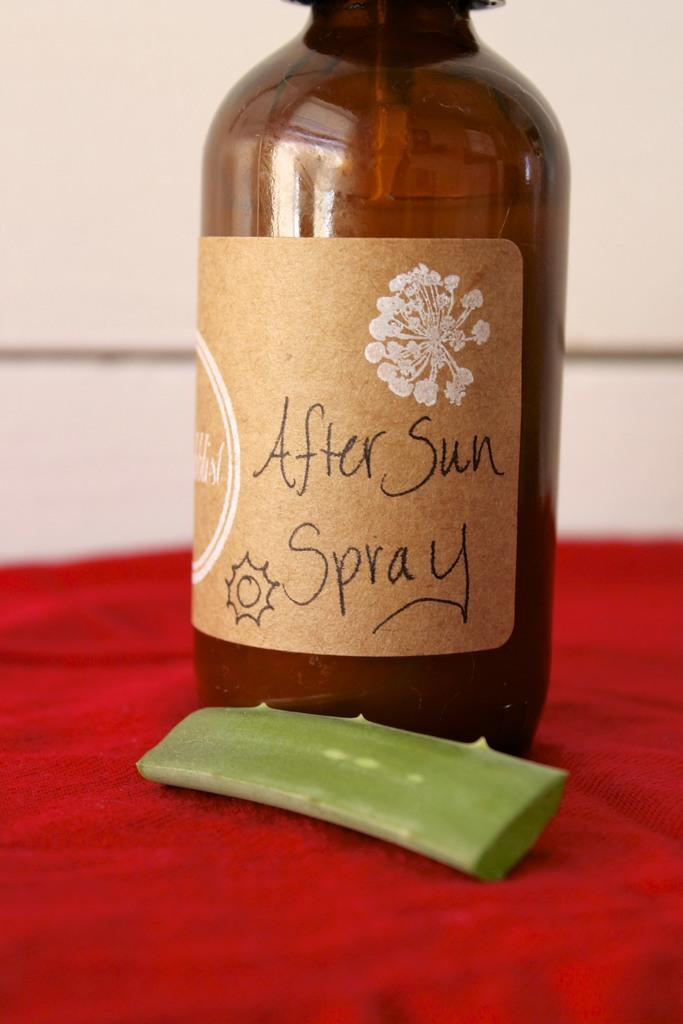What object is present in the image that might contain a liquid or other substance? There is a bottle in the image. What is inside the bottle? The bottle contains a red-colored cloth. What plant-based item is visible in the image? There is an aloe vera stem in the image. How does the calculator help with the walk in the image? There is no calculator present in the image, and therefore it cannot help with any walk. 